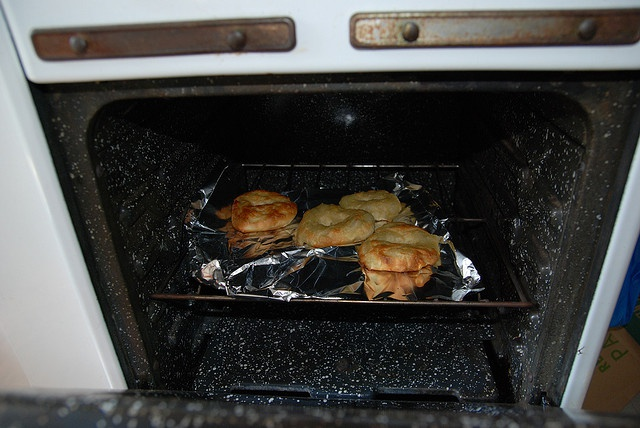Describe the objects in this image and their specific colors. I can see oven in black, darkgray, lightgray, and gray tones, donut in darkgray, olive, brown, and maroon tones, donut in darkgray, olive, and maroon tones, donut in darkgray, maroon, brown, and black tones, and donut in darkgray, olive, and black tones in this image. 